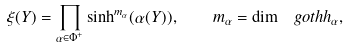Convert formula to latex. <formula><loc_0><loc_0><loc_500><loc_500>\xi ( Y ) = \prod _ { \alpha \in \Phi ^ { + } } \sinh ^ { m _ { \alpha } } ( \alpha ( Y ) ) , \quad m _ { \alpha } = \dim \ g o t h { h } _ { \alpha } ,</formula> 